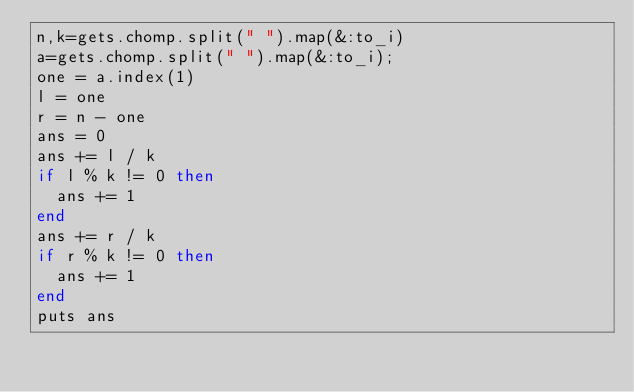Convert code to text. <code><loc_0><loc_0><loc_500><loc_500><_Ruby_>n,k=gets.chomp.split(" ").map(&:to_i)
a=gets.chomp.split(" ").map(&:to_i);
one = a.index(1)
l = one
r = n - one
ans = 0
ans += l / k
if l % k != 0 then
  ans += 1
end
ans += r / k
if r % k != 0 then
  ans += 1
end
puts ans
</code> 